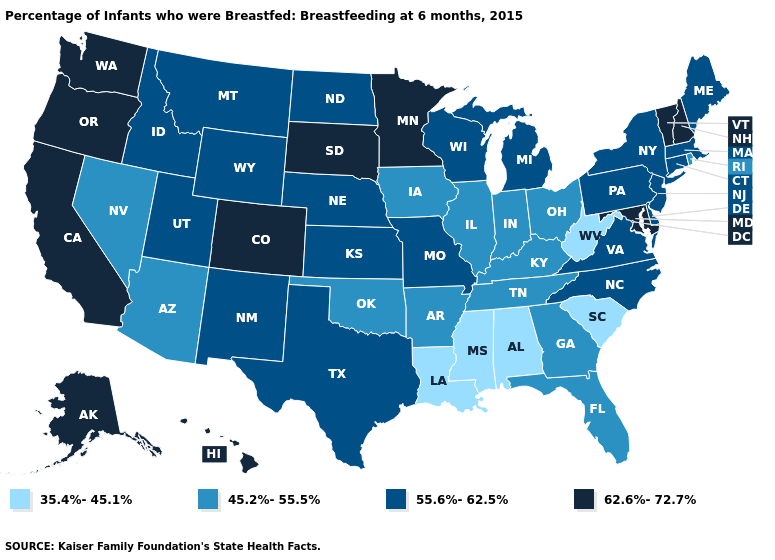What is the lowest value in the USA?
Answer briefly. 35.4%-45.1%. What is the lowest value in states that border South Carolina?
Give a very brief answer. 45.2%-55.5%. What is the lowest value in states that border Texas?
Keep it brief. 35.4%-45.1%. What is the highest value in states that border North Carolina?
Be succinct. 55.6%-62.5%. What is the value of Texas?
Answer briefly. 55.6%-62.5%. Name the states that have a value in the range 55.6%-62.5%?
Be succinct. Connecticut, Delaware, Idaho, Kansas, Maine, Massachusetts, Michigan, Missouri, Montana, Nebraska, New Jersey, New Mexico, New York, North Carolina, North Dakota, Pennsylvania, Texas, Utah, Virginia, Wisconsin, Wyoming. Which states have the highest value in the USA?
Be succinct. Alaska, California, Colorado, Hawaii, Maryland, Minnesota, New Hampshire, Oregon, South Dakota, Vermont, Washington. Among the states that border South Carolina , does North Carolina have the highest value?
Answer briefly. Yes. Name the states that have a value in the range 45.2%-55.5%?
Short answer required. Arizona, Arkansas, Florida, Georgia, Illinois, Indiana, Iowa, Kentucky, Nevada, Ohio, Oklahoma, Rhode Island, Tennessee. Does Florida have a lower value than Rhode Island?
Keep it brief. No. What is the value of North Carolina?
Give a very brief answer. 55.6%-62.5%. What is the highest value in states that border Wisconsin?
Write a very short answer. 62.6%-72.7%. What is the value of Wisconsin?
Give a very brief answer. 55.6%-62.5%. What is the value of Florida?
Write a very short answer. 45.2%-55.5%. Does the map have missing data?
Keep it brief. No. 